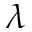<formula> <loc_0><loc_0><loc_500><loc_500>\lambda</formula> 